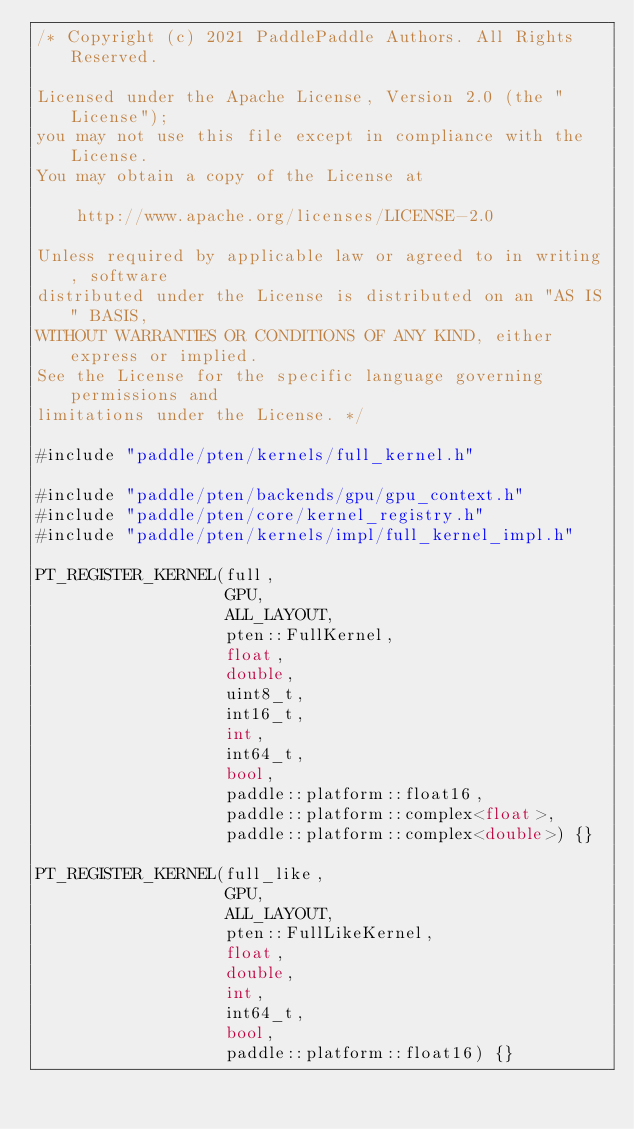<code> <loc_0><loc_0><loc_500><loc_500><_Cuda_>/* Copyright (c) 2021 PaddlePaddle Authors. All Rights Reserved.

Licensed under the Apache License, Version 2.0 (the "License");
you may not use this file except in compliance with the License.
You may obtain a copy of the License at

    http://www.apache.org/licenses/LICENSE-2.0

Unless required by applicable law or agreed to in writing, software
distributed under the License is distributed on an "AS IS" BASIS,
WITHOUT WARRANTIES OR CONDITIONS OF ANY KIND, either express or implied.
See the License for the specific language governing permissions and
limitations under the License. */

#include "paddle/pten/kernels/full_kernel.h"

#include "paddle/pten/backends/gpu/gpu_context.h"
#include "paddle/pten/core/kernel_registry.h"
#include "paddle/pten/kernels/impl/full_kernel_impl.h"

PT_REGISTER_KERNEL(full,
                   GPU,
                   ALL_LAYOUT,
                   pten::FullKernel,
                   float,
                   double,
                   uint8_t,
                   int16_t,
                   int,
                   int64_t,
                   bool,
                   paddle::platform::float16,
                   paddle::platform::complex<float>,
                   paddle::platform::complex<double>) {}

PT_REGISTER_KERNEL(full_like,
                   GPU,
                   ALL_LAYOUT,
                   pten::FullLikeKernel,
                   float,
                   double,
                   int,
                   int64_t,
                   bool,
                   paddle::platform::float16) {}
</code> 